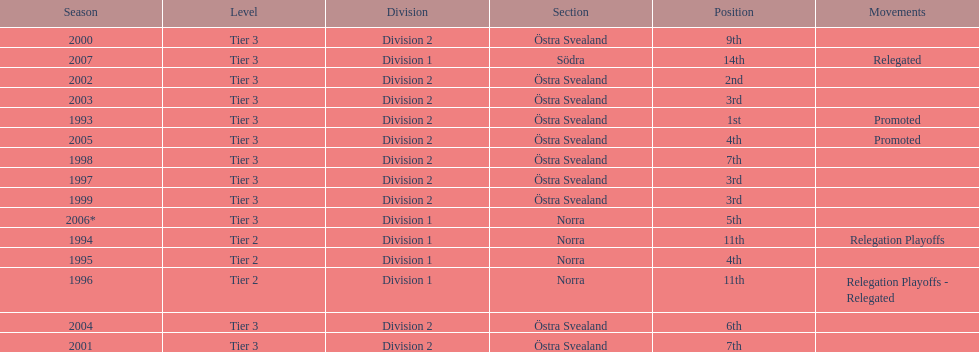In what season did visby if gute fk finish first in division 2 tier 3? 1993. 